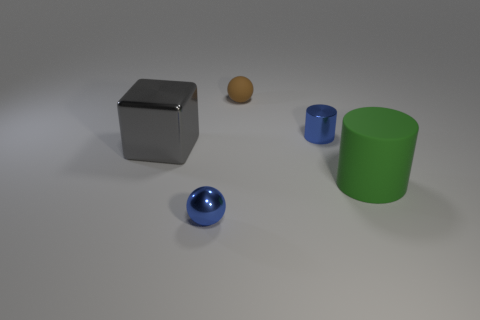Add 2 tiny objects. How many objects exist? 7 Subtract all balls. How many objects are left? 3 Subtract all tiny blue cylinders. Subtract all big gray metallic objects. How many objects are left? 3 Add 1 small brown matte spheres. How many small brown matte spheres are left? 2 Add 5 large green matte objects. How many large green matte objects exist? 6 Subtract 0 brown blocks. How many objects are left? 5 